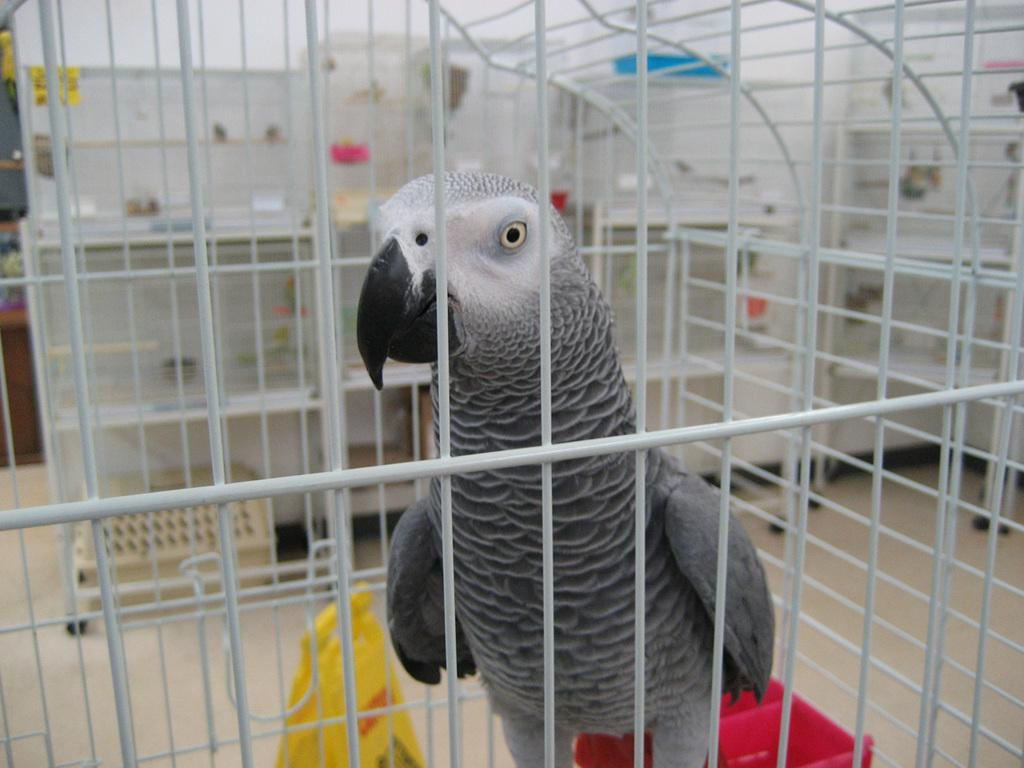What animal is sitting on the table in the image? There is a cat sitting on the table in the image. What else can be seen on the table besides the cat? There are books and a cup on the table in the image. Can you tell me how many divisions are present in the image? There is no mention of divisions in the image; it features a cat sitting on a table with books and a cup. What type of sand can be seen on the table in the image? There is no sand present on the table in the image; it features a cat sitting on a table with books and a cup. 